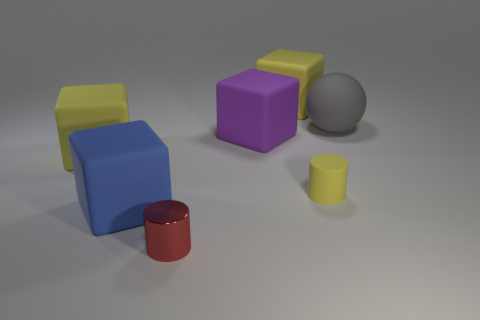Is the number of cylinders less than the number of tiny gray blocks? no 